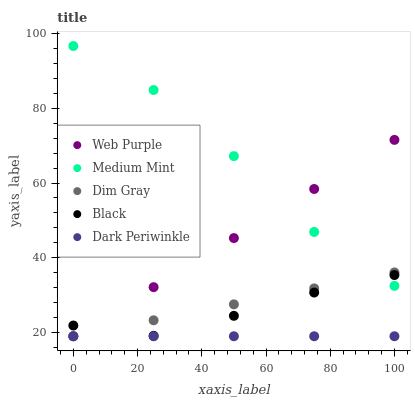Does Dark Periwinkle have the minimum area under the curve?
Answer yes or no. Yes. Does Medium Mint have the maximum area under the curve?
Answer yes or no. Yes. Does Web Purple have the minimum area under the curve?
Answer yes or no. No. Does Web Purple have the maximum area under the curve?
Answer yes or no. No. Is Dark Periwinkle the smoothest?
Answer yes or no. Yes. Is Medium Mint the roughest?
Answer yes or no. Yes. Is Web Purple the smoothest?
Answer yes or no. No. Is Web Purple the roughest?
Answer yes or no. No. Does Web Purple have the lowest value?
Answer yes or no. Yes. Does Black have the lowest value?
Answer yes or no. No. Does Medium Mint have the highest value?
Answer yes or no. Yes. Does Web Purple have the highest value?
Answer yes or no. No. Is Dark Periwinkle less than Medium Mint?
Answer yes or no. Yes. Is Black greater than Dark Periwinkle?
Answer yes or no. Yes. Does Web Purple intersect Dim Gray?
Answer yes or no. Yes. Is Web Purple less than Dim Gray?
Answer yes or no. No. Is Web Purple greater than Dim Gray?
Answer yes or no. No. Does Dark Periwinkle intersect Medium Mint?
Answer yes or no. No. 